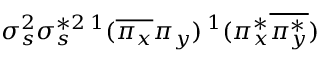<formula> <loc_0><loc_0><loc_500><loc_500>\sigma _ { s } ^ { 2 } \sigma _ { s } ^ { * 2 \, ^ { 1 } ( \overline { { \pi _ { x } } } \pi _ { y } \, ^ { 1 } ( \pi _ { x } ^ { * } \overline { { \pi _ { y } ^ { * } } } )</formula> 